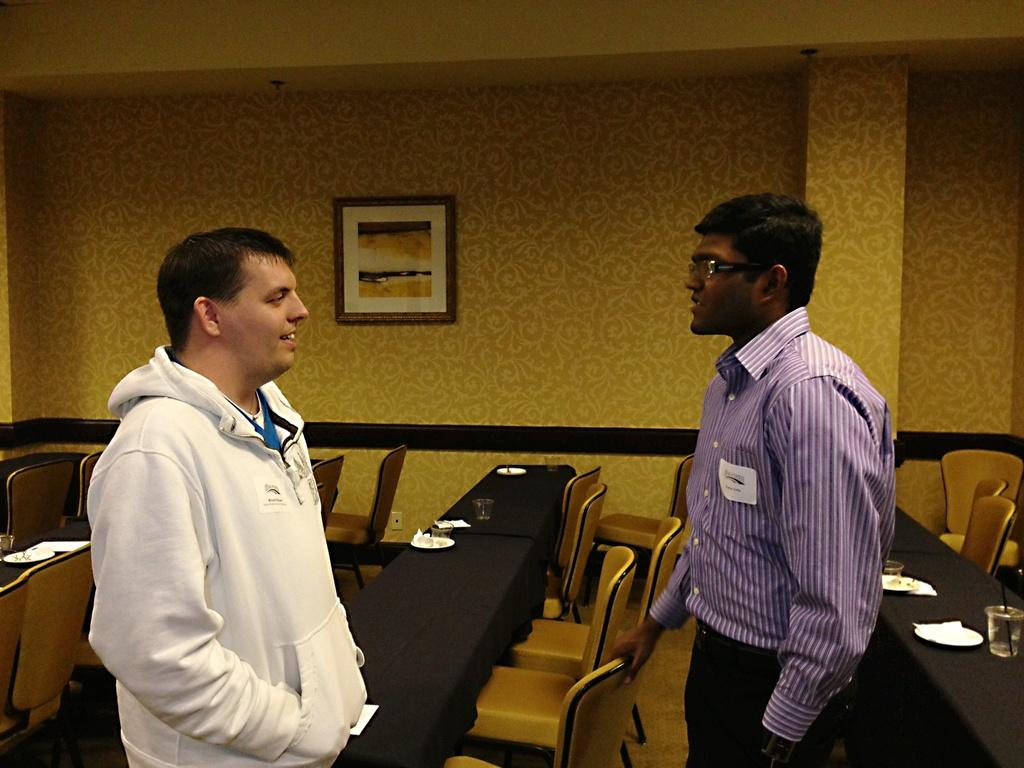What can be seen in the background of the image? There is a wall in the image. What is hanging on the wall? There is a photo frame in the image. How many people are present in the image? There are two people standing in the image. What type of furniture is visible in the image? There are chairs and tables in the image. What items are on the tables? There are plates and glasses on the tables. What type of head injury is being treated in the hospital in the image? There is no hospital or head injury present in the image; it features a wall, photo frame, people, chairs, tables, plates, and glasses. 